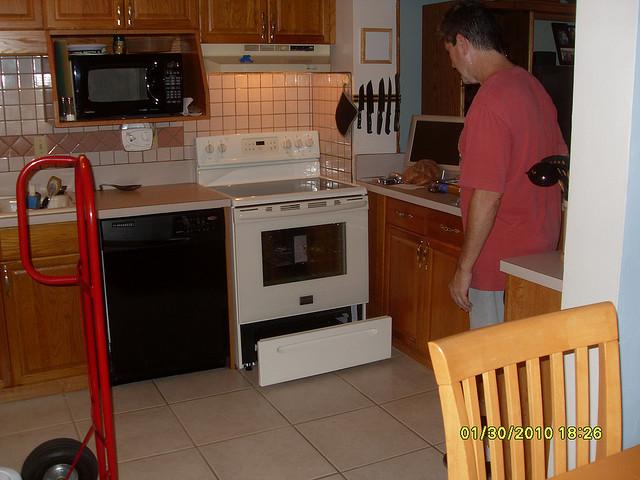How many knives are hanging on the wall?
Concise answer only. 5. What time was the photo taken?
Be succinct. 18:26. What is the color of the stove?
Write a very short answer. White. 